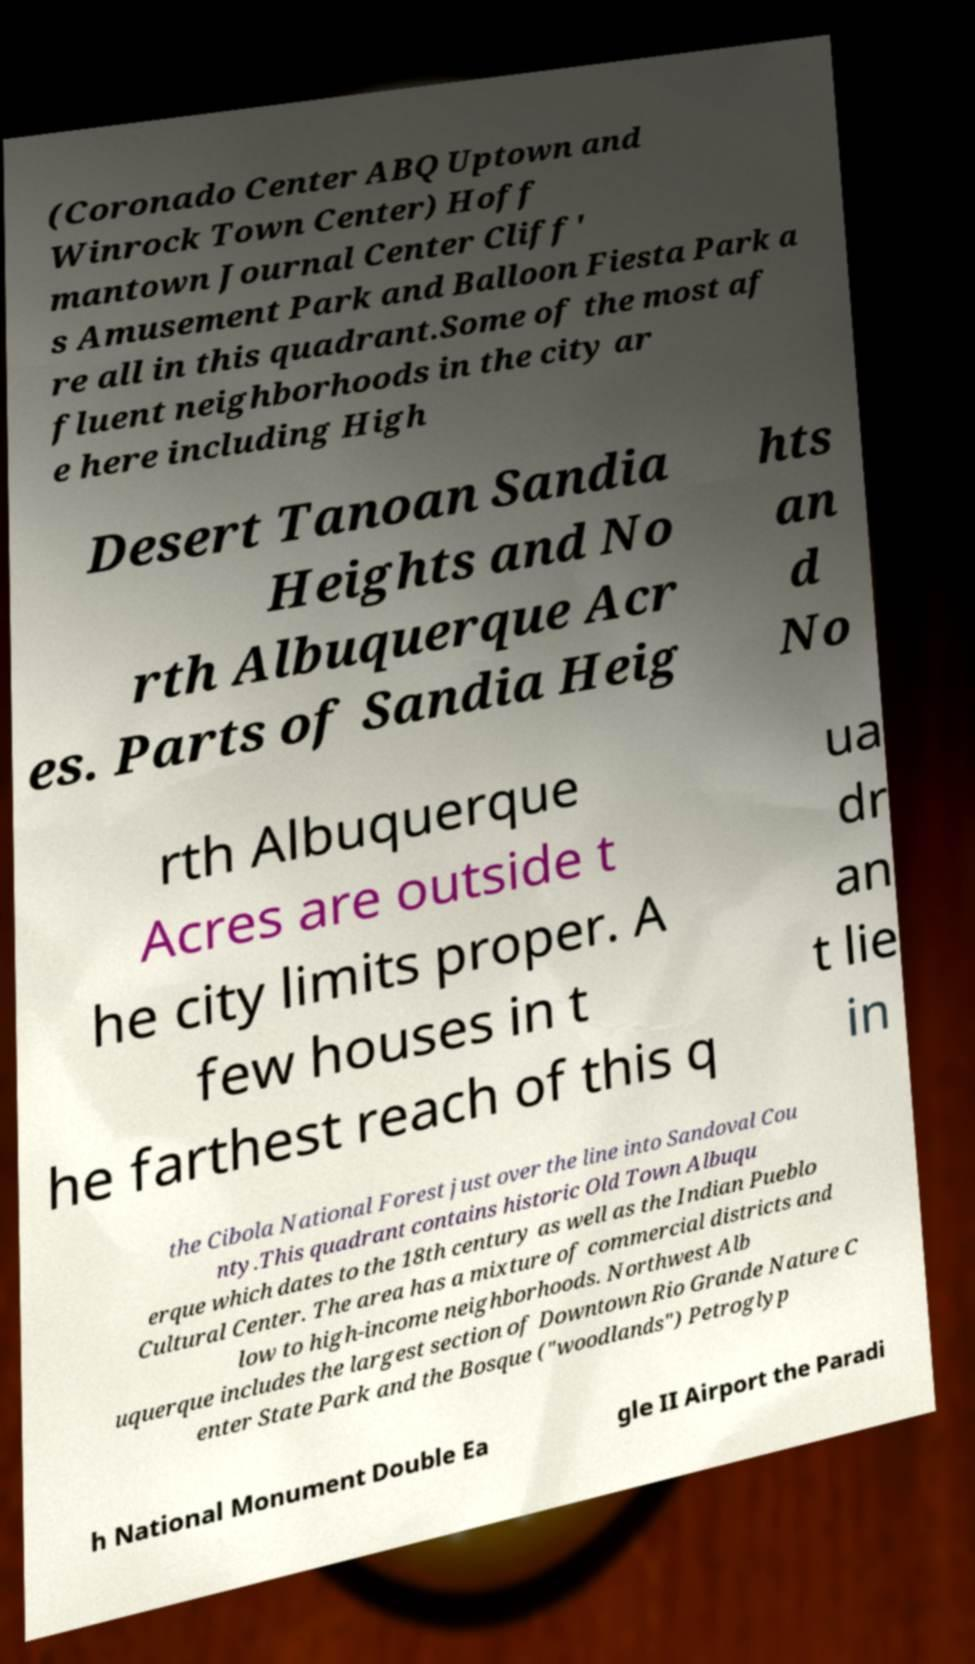Please identify and transcribe the text found in this image. (Coronado Center ABQ Uptown and Winrock Town Center) Hoff mantown Journal Center Cliff' s Amusement Park and Balloon Fiesta Park a re all in this quadrant.Some of the most af fluent neighborhoods in the city ar e here including High Desert Tanoan Sandia Heights and No rth Albuquerque Acr es. Parts of Sandia Heig hts an d No rth Albuquerque Acres are outside t he city limits proper. A few houses in t he farthest reach of this q ua dr an t lie in the Cibola National Forest just over the line into Sandoval Cou nty.This quadrant contains historic Old Town Albuqu erque which dates to the 18th century as well as the Indian Pueblo Cultural Center. The area has a mixture of commercial districts and low to high-income neighborhoods. Northwest Alb uquerque includes the largest section of Downtown Rio Grande Nature C enter State Park and the Bosque ("woodlands") Petroglyp h National Monument Double Ea gle II Airport the Paradi 